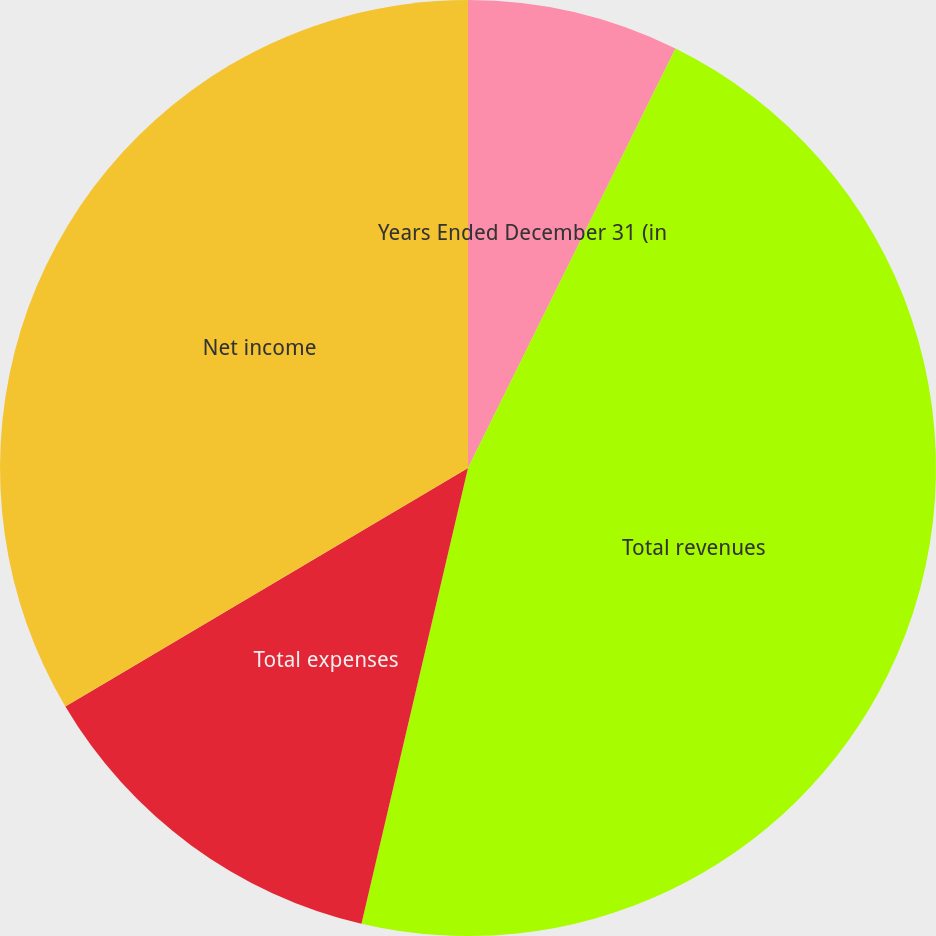Convert chart. <chart><loc_0><loc_0><loc_500><loc_500><pie_chart><fcel>Years Ended December 31 (in<fcel>Total revenues<fcel>Total expenses<fcel>Net income<nl><fcel>7.31%<fcel>46.34%<fcel>12.83%<fcel>33.51%<nl></chart> 